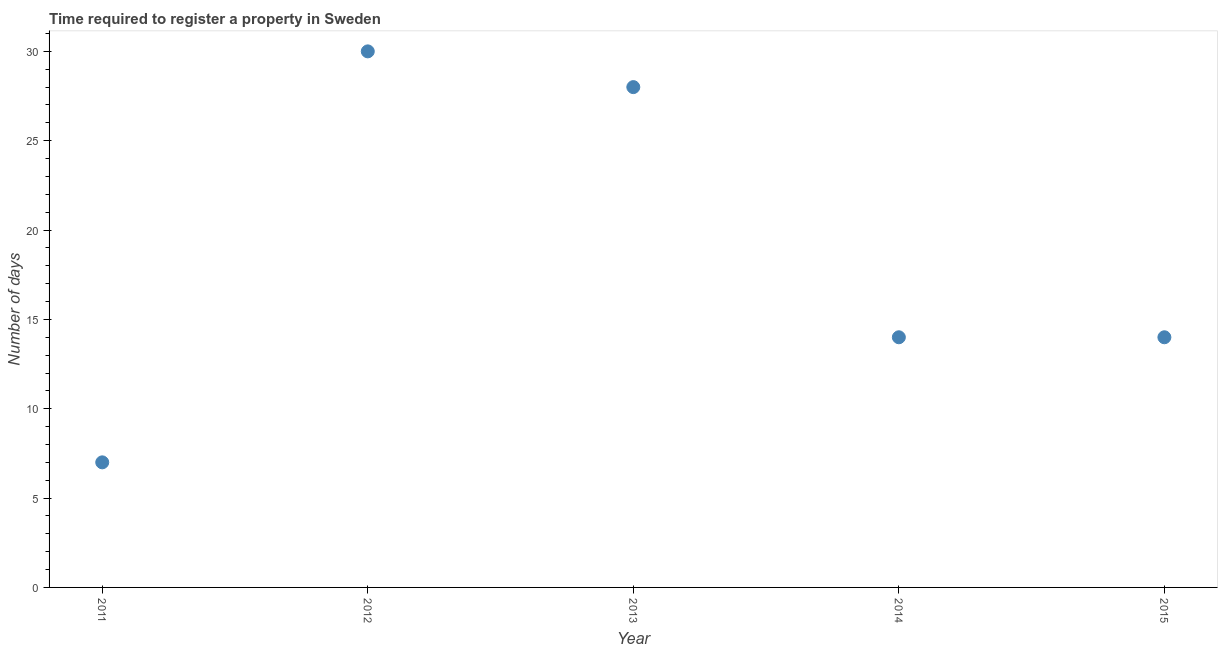What is the number of days required to register property in 2013?
Keep it short and to the point. 28. Across all years, what is the maximum number of days required to register property?
Your answer should be compact. 30. Across all years, what is the minimum number of days required to register property?
Provide a succinct answer. 7. In which year was the number of days required to register property minimum?
Keep it short and to the point. 2011. What is the sum of the number of days required to register property?
Provide a short and direct response. 93. What is the difference between the number of days required to register property in 2011 and 2012?
Your answer should be compact. -23. What is the average number of days required to register property per year?
Give a very brief answer. 18.6. In how many years, is the number of days required to register property greater than 25 days?
Your answer should be compact. 2. What is the ratio of the number of days required to register property in 2012 to that in 2014?
Make the answer very short. 2.14. Is the number of days required to register property in 2011 less than that in 2015?
Provide a succinct answer. Yes. Is the difference between the number of days required to register property in 2011 and 2015 greater than the difference between any two years?
Your answer should be compact. No. What is the difference between the highest and the second highest number of days required to register property?
Give a very brief answer. 2. What is the difference between the highest and the lowest number of days required to register property?
Offer a very short reply. 23. In how many years, is the number of days required to register property greater than the average number of days required to register property taken over all years?
Keep it short and to the point. 2. Does the number of days required to register property monotonically increase over the years?
Make the answer very short. No. How many dotlines are there?
Your answer should be compact. 1. How many years are there in the graph?
Your response must be concise. 5. What is the difference between two consecutive major ticks on the Y-axis?
Offer a very short reply. 5. Are the values on the major ticks of Y-axis written in scientific E-notation?
Make the answer very short. No. Does the graph contain grids?
Provide a succinct answer. No. What is the title of the graph?
Give a very brief answer. Time required to register a property in Sweden. What is the label or title of the Y-axis?
Ensure brevity in your answer.  Number of days. What is the Number of days in 2012?
Give a very brief answer. 30. What is the Number of days in 2013?
Ensure brevity in your answer.  28. What is the Number of days in 2014?
Offer a terse response. 14. What is the Number of days in 2015?
Make the answer very short. 14. What is the difference between the Number of days in 2011 and 2012?
Your answer should be very brief. -23. What is the difference between the Number of days in 2011 and 2014?
Your response must be concise. -7. What is the difference between the Number of days in 2012 and 2013?
Ensure brevity in your answer.  2. What is the difference between the Number of days in 2012 and 2015?
Give a very brief answer. 16. What is the ratio of the Number of days in 2011 to that in 2012?
Your response must be concise. 0.23. What is the ratio of the Number of days in 2011 to that in 2013?
Your answer should be compact. 0.25. What is the ratio of the Number of days in 2011 to that in 2014?
Keep it short and to the point. 0.5. What is the ratio of the Number of days in 2011 to that in 2015?
Offer a very short reply. 0.5. What is the ratio of the Number of days in 2012 to that in 2013?
Provide a short and direct response. 1.07. What is the ratio of the Number of days in 2012 to that in 2014?
Your answer should be very brief. 2.14. What is the ratio of the Number of days in 2012 to that in 2015?
Make the answer very short. 2.14. What is the ratio of the Number of days in 2013 to that in 2015?
Give a very brief answer. 2. 